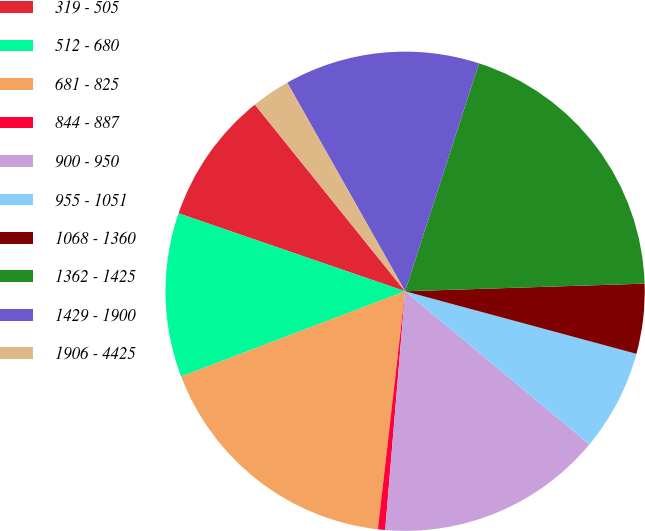Convert chart to OTSL. <chart><loc_0><loc_0><loc_500><loc_500><pie_chart><fcel>319 - 505<fcel>512 - 680<fcel>681 - 825<fcel>844 - 887<fcel>900 - 950<fcel>955 - 1051<fcel>1068 - 1360<fcel>1362 - 1425<fcel>1429 - 1900<fcel>1906 - 4425<nl><fcel>8.94%<fcel>11.06%<fcel>17.4%<fcel>0.49%<fcel>15.29%<fcel>6.83%<fcel>4.71%<fcel>19.51%<fcel>13.17%<fcel>2.6%<nl></chart> 